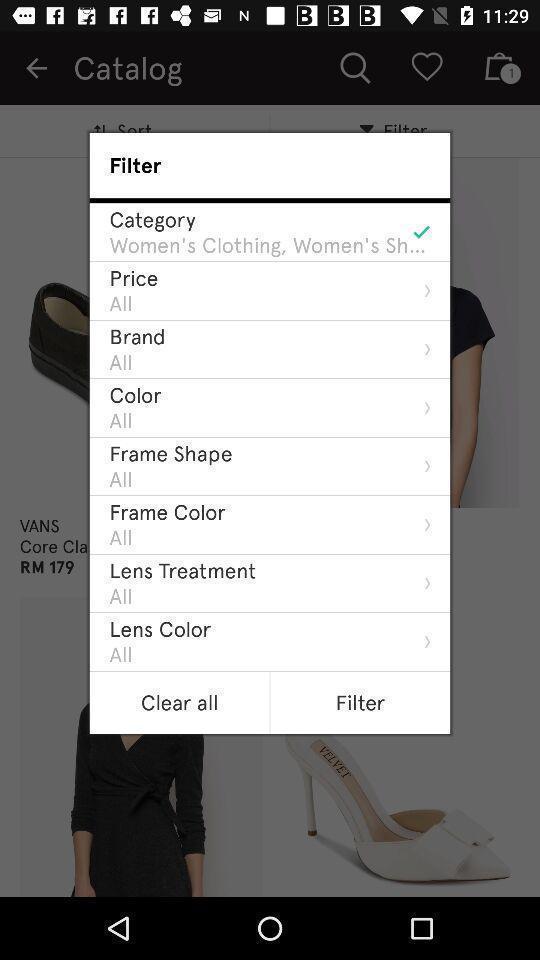Please provide a description for this image. Pop-up page displaying with different filter options. 